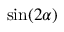Convert formula to latex. <formula><loc_0><loc_0><loc_500><loc_500>\sin ( 2 \alpha )</formula> 